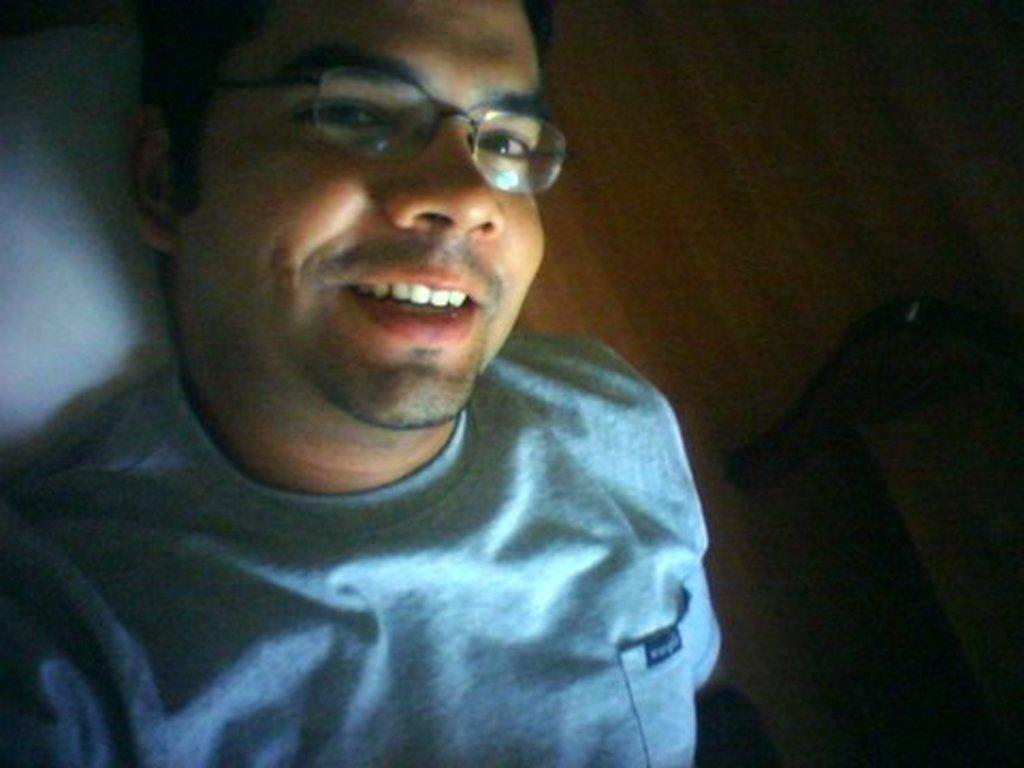What is the main subject of the image? The main subject of the image is a man. Can you describe the man's appearance in the image? The man is wearing specs and a t-shirt. What is the man's facial expression in the image? The man is smiling in the image. How would you describe the background of the image? The background of the image is blurred. What type of drum can be seen being played by ants in the image? There is no drum or ants present in the image. Can you describe the fog in the image? There is no fog present in the image. 